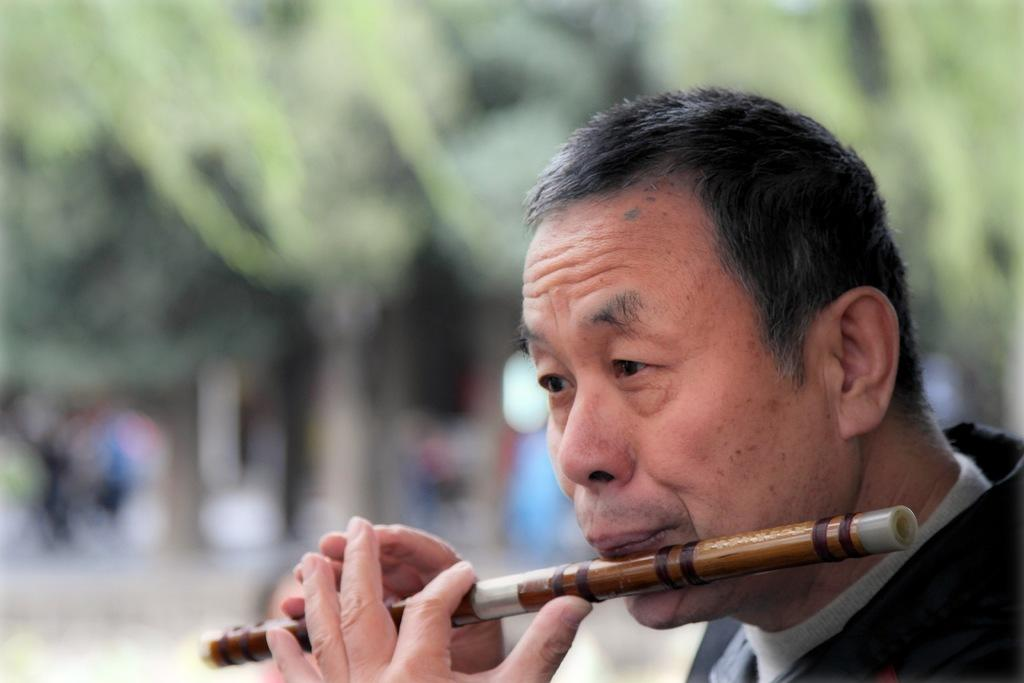What is happening in the image? There is a person in the image, and they are playing the flute. Can you describe the person's activity in more detail? The person is playing a musical instrument, specifically the flute. What type of plant is growing out of the person's head in the image? There is no plant growing out of the person's head in the image; the person is simply playing the flute. 